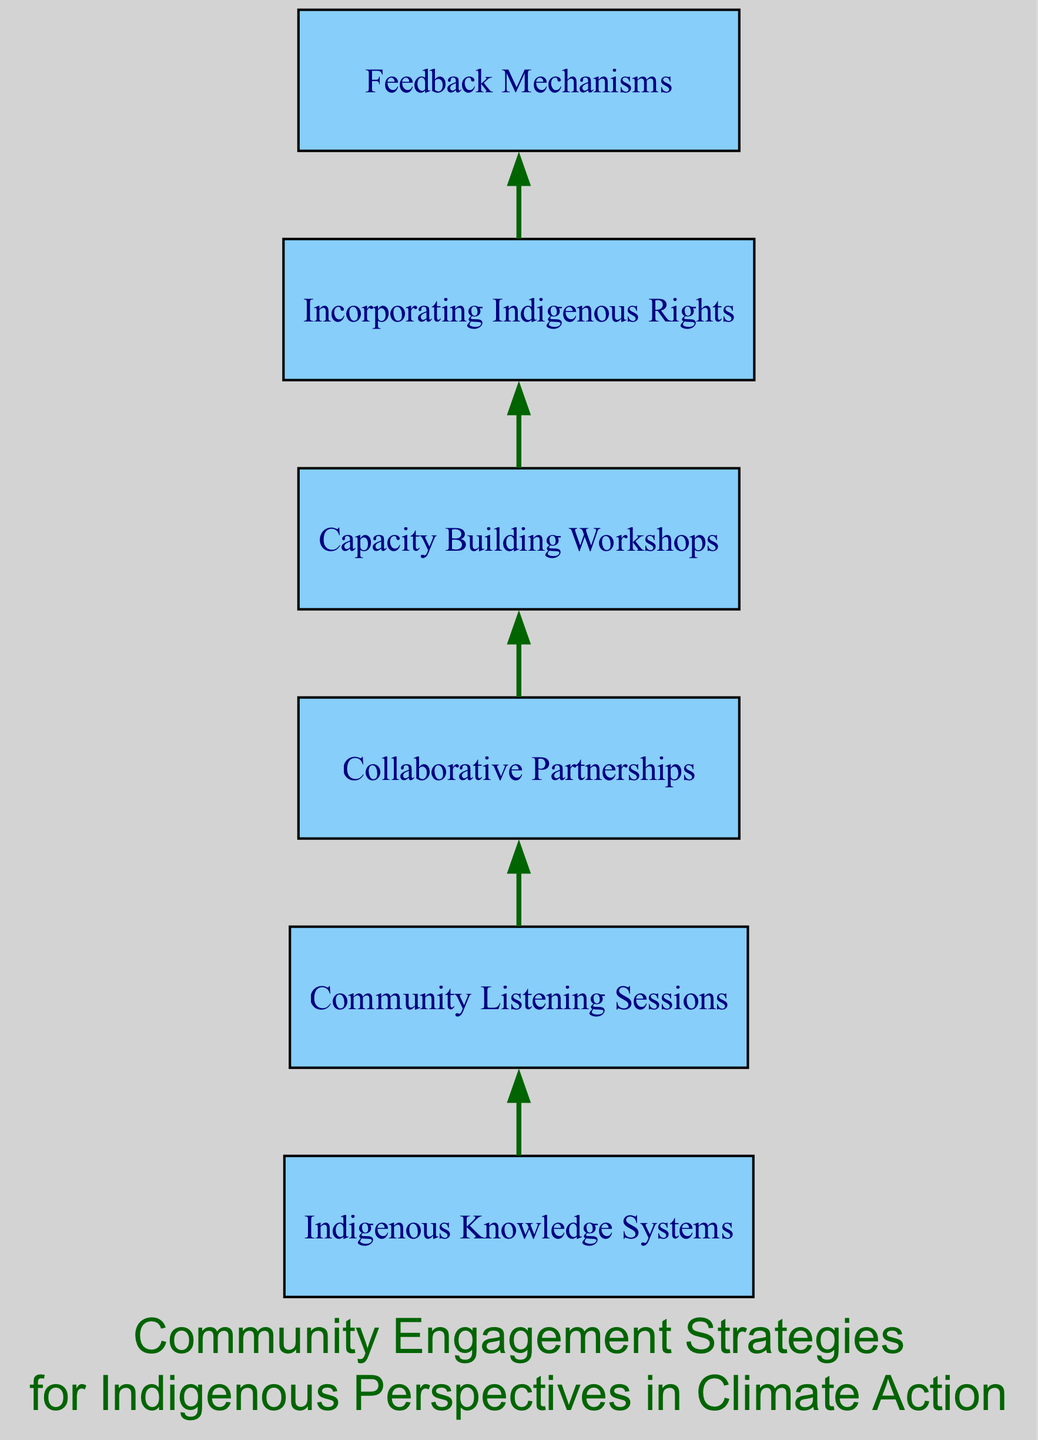What is the first element in the diagram? The first element, based on the bottom-up layout, is "Indigenous Knowledge Systems." It is the initial step in the engagement strategies as seen at the bottom of the flow chart.
Answer: Indigenous Knowledge Systems How many elements are in the diagram? The diagram contains six distinct elements, including "Indigenous Knowledge Systems" through to "Feedback Mechanisms." Each represents a different aspect of community engagement strategies.
Answer: 6 What connects "Community Listening Sessions" to "Collaborative Partnerships"? "Community Listening Sessions" leads to "Collaborative Partnerships" in the flow chart, indicating that listening to the community is essential for building partnerships. The connection goes from one node to the next sequentially.
Answer: dark green edge Which element emphasizes the importance of Indigenous rights? The element titled "Incorporating Indigenous Rights" addresses the significance of ensuring that climate policies respect the self-determination and land rights of Indigenous peoples.
Answer: Incorporating Indigenous Rights What flow direction does this diagram follow? The diagram follows a bottom-to-top flow direction, as indicated by the arrangement of elements from "Indigenous Knowledge Systems" at the bottom to "Feedback Mechanisms" at the top. This structure supports the implementation of strategies in a hierarchically supportive way.
Answer: Bottom-to-top Which element is positioned last in the flow chart? The last element in the flow chart is "Feedback Mechanisms," highlighting the need for ongoing input from Indigenous representatives after the initial strategies have been proposed and implemented.
Answer: Feedback Mechanisms Why are "Capacity Building Workshops" necessary? "Capacity Building Workshops" focus on providing training for Indigenous communities in sustainable practices and climate action advocacy. This is vital for empowering communities to engage effectively in climate action initiatives.
Answer: Empower communities What is the role of "Feedback Mechanisms" in the diagram? "Feedback Mechanisms" play a crucial role by establishing channels for ongoing input from Indigenous representatives to refine climate initiatives, ensuring that the strategies remain relevant and effective based on community feedback.
Answer: Refining climate initiatives 